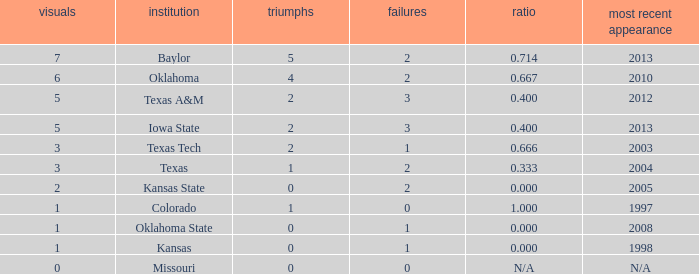How many wins did Baylor have?  1.0. 